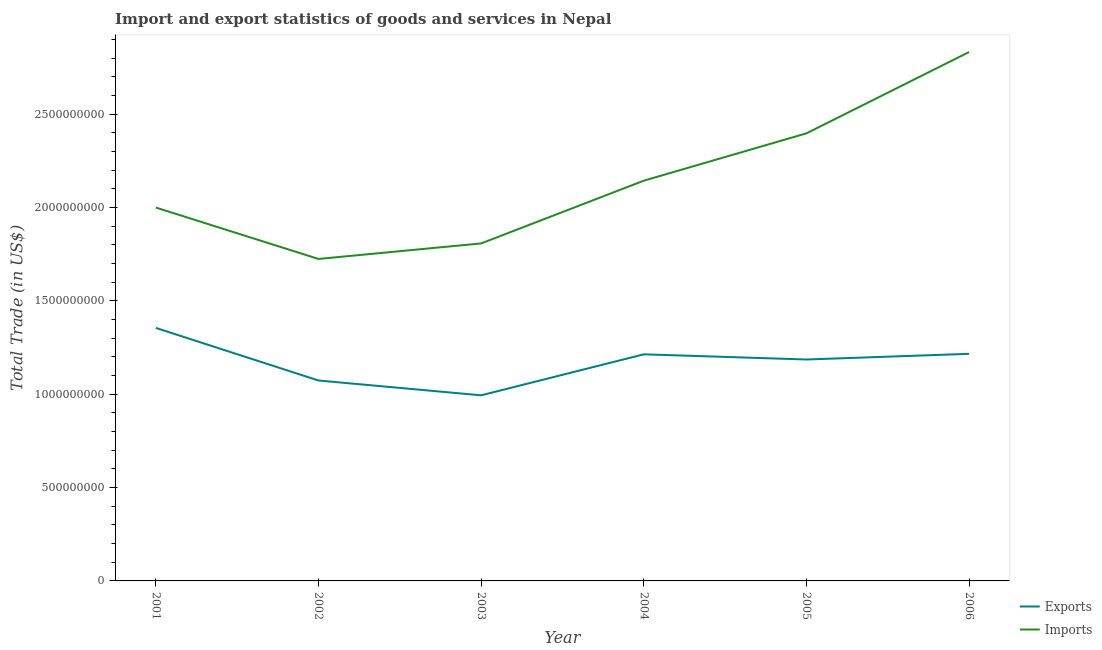How many different coloured lines are there?
Your answer should be compact. 2. Does the line corresponding to export of goods and services intersect with the line corresponding to imports of goods and services?
Your answer should be compact. No. What is the imports of goods and services in 2001?
Give a very brief answer. 2.00e+09. Across all years, what is the maximum imports of goods and services?
Ensure brevity in your answer.  2.83e+09. Across all years, what is the minimum imports of goods and services?
Your response must be concise. 1.72e+09. In which year was the imports of goods and services maximum?
Ensure brevity in your answer.  2006. In which year was the export of goods and services minimum?
Offer a very short reply. 2003. What is the total imports of goods and services in the graph?
Your answer should be very brief. 1.29e+1. What is the difference between the imports of goods and services in 2001 and that in 2002?
Provide a short and direct response. 2.75e+08. What is the difference between the export of goods and services in 2006 and the imports of goods and services in 2003?
Provide a succinct answer. -5.91e+08. What is the average imports of goods and services per year?
Provide a short and direct response. 2.15e+09. In the year 2005, what is the difference between the imports of goods and services and export of goods and services?
Your answer should be very brief. 1.21e+09. In how many years, is the imports of goods and services greater than 1500000000 US$?
Offer a terse response. 6. What is the ratio of the export of goods and services in 2005 to that in 2006?
Keep it short and to the point. 0.98. What is the difference between the highest and the second highest imports of goods and services?
Your answer should be very brief. 4.35e+08. What is the difference between the highest and the lowest export of goods and services?
Your answer should be compact. 3.61e+08. Is the imports of goods and services strictly greater than the export of goods and services over the years?
Your answer should be compact. Yes. How many years are there in the graph?
Ensure brevity in your answer.  6. Are the values on the major ticks of Y-axis written in scientific E-notation?
Provide a succinct answer. No. Does the graph contain any zero values?
Provide a short and direct response. No. Does the graph contain grids?
Your answer should be very brief. No. How many legend labels are there?
Provide a succinct answer. 2. How are the legend labels stacked?
Keep it short and to the point. Vertical. What is the title of the graph?
Offer a very short reply. Import and export statistics of goods and services in Nepal. What is the label or title of the X-axis?
Offer a terse response. Year. What is the label or title of the Y-axis?
Keep it short and to the point. Total Trade (in US$). What is the Total Trade (in US$) of Exports in 2001?
Provide a short and direct response. 1.35e+09. What is the Total Trade (in US$) in Imports in 2001?
Your answer should be very brief. 2.00e+09. What is the Total Trade (in US$) in Exports in 2002?
Give a very brief answer. 1.07e+09. What is the Total Trade (in US$) of Imports in 2002?
Offer a very short reply. 1.72e+09. What is the Total Trade (in US$) in Exports in 2003?
Keep it short and to the point. 9.94e+08. What is the Total Trade (in US$) of Imports in 2003?
Give a very brief answer. 1.81e+09. What is the Total Trade (in US$) of Exports in 2004?
Your answer should be very brief. 1.21e+09. What is the Total Trade (in US$) of Imports in 2004?
Your response must be concise. 2.14e+09. What is the Total Trade (in US$) of Exports in 2005?
Your response must be concise. 1.19e+09. What is the Total Trade (in US$) in Imports in 2005?
Your answer should be compact. 2.40e+09. What is the Total Trade (in US$) in Exports in 2006?
Provide a succinct answer. 1.22e+09. What is the Total Trade (in US$) of Imports in 2006?
Provide a short and direct response. 2.83e+09. Across all years, what is the maximum Total Trade (in US$) in Exports?
Ensure brevity in your answer.  1.35e+09. Across all years, what is the maximum Total Trade (in US$) in Imports?
Keep it short and to the point. 2.83e+09. Across all years, what is the minimum Total Trade (in US$) of Exports?
Offer a very short reply. 9.94e+08. Across all years, what is the minimum Total Trade (in US$) of Imports?
Keep it short and to the point. 1.72e+09. What is the total Total Trade (in US$) in Exports in the graph?
Your answer should be compact. 7.04e+09. What is the total Total Trade (in US$) in Imports in the graph?
Your response must be concise. 1.29e+1. What is the difference between the Total Trade (in US$) in Exports in 2001 and that in 2002?
Provide a succinct answer. 2.82e+08. What is the difference between the Total Trade (in US$) in Imports in 2001 and that in 2002?
Keep it short and to the point. 2.75e+08. What is the difference between the Total Trade (in US$) of Exports in 2001 and that in 2003?
Your response must be concise. 3.61e+08. What is the difference between the Total Trade (in US$) in Imports in 2001 and that in 2003?
Offer a terse response. 1.92e+08. What is the difference between the Total Trade (in US$) in Exports in 2001 and that in 2004?
Your response must be concise. 1.41e+08. What is the difference between the Total Trade (in US$) in Imports in 2001 and that in 2004?
Provide a succinct answer. -1.44e+08. What is the difference between the Total Trade (in US$) in Exports in 2001 and that in 2005?
Give a very brief answer. 1.69e+08. What is the difference between the Total Trade (in US$) of Imports in 2001 and that in 2005?
Your response must be concise. -3.97e+08. What is the difference between the Total Trade (in US$) in Exports in 2001 and that in 2006?
Your answer should be very brief. 1.39e+08. What is the difference between the Total Trade (in US$) of Imports in 2001 and that in 2006?
Your answer should be compact. -8.33e+08. What is the difference between the Total Trade (in US$) of Exports in 2002 and that in 2003?
Provide a short and direct response. 7.94e+07. What is the difference between the Total Trade (in US$) in Imports in 2002 and that in 2003?
Your response must be concise. -8.31e+07. What is the difference between the Total Trade (in US$) of Exports in 2002 and that in 2004?
Provide a succinct answer. -1.40e+08. What is the difference between the Total Trade (in US$) of Imports in 2002 and that in 2004?
Your answer should be very brief. -4.19e+08. What is the difference between the Total Trade (in US$) of Exports in 2002 and that in 2005?
Offer a very short reply. -1.12e+08. What is the difference between the Total Trade (in US$) of Imports in 2002 and that in 2005?
Provide a succinct answer. -6.73e+08. What is the difference between the Total Trade (in US$) in Exports in 2002 and that in 2006?
Ensure brevity in your answer.  -1.43e+08. What is the difference between the Total Trade (in US$) in Imports in 2002 and that in 2006?
Make the answer very short. -1.11e+09. What is the difference between the Total Trade (in US$) of Exports in 2003 and that in 2004?
Provide a succinct answer. -2.20e+08. What is the difference between the Total Trade (in US$) of Imports in 2003 and that in 2004?
Your answer should be very brief. -3.36e+08. What is the difference between the Total Trade (in US$) in Exports in 2003 and that in 2005?
Your answer should be very brief. -1.92e+08. What is the difference between the Total Trade (in US$) in Imports in 2003 and that in 2005?
Your answer should be very brief. -5.90e+08. What is the difference between the Total Trade (in US$) in Exports in 2003 and that in 2006?
Provide a short and direct response. -2.22e+08. What is the difference between the Total Trade (in US$) in Imports in 2003 and that in 2006?
Give a very brief answer. -1.02e+09. What is the difference between the Total Trade (in US$) in Exports in 2004 and that in 2005?
Offer a terse response. 2.78e+07. What is the difference between the Total Trade (in US$) of Imports in 2004 and that in 2005?
Keep it short and to the point. -2.54e+08. What is the difference between the Total Trade (in US$) in Exports in 2004 and that in 2006?
Your response must be concise. -2.58e+06. What is the difference between the Total Trade (in US$) of Imports in 2004 and that in 2006?
Your response must be concise. -6.89e+08. What is the difference between the Total Trade (in US$) in Exports in 2005 and that in 2006?
Provide a short and direct response. -3.04e+07. What is the difference between the Total Trade (in US$) of Imports in 2005 and that in 2006?
Provide a succinct answer. -4.35e+08. What is the difference between the Total Trade (in US$) of Exports in 2001 and the Total Trade (in US$) of Imports in 2002?
Offer a terse response. -3.69e+08. What is the difference between the Total Trade (in US$) of Exports in 2001 and the Total Trade (in US$) of Imports in 2003?
Your answer should be compact. -4.52e+08. What is the difference between the Total Trade (in US$) in Exports in 2001 and the Total Trade (in US$) in Imports in 2004?
Your response must be concise. -7.88e+08. What is the difference between the Total Trade (in US$) in Exports in 2001 and the Total Trade (in US$) in Imports in 2005?
Your response must be concise. -1.04e+09. What is the difference between the Total Trade (in US$) in Exports in 2001 and the Total Trade (in US$) in Imports in 2006?
Provide a short and direct response. -1.48e+09. What is the difference between the Total Trade (in US$) in Exports in 2002 and the Total Trade (in US$) in Imports in 2003?
Your response must be concise. -7.34e+08. What is the difference between the Total Trade (in US$) of Exports in 2002 and the Total Trade (in US$) of Imports in 2004?
Keep it short and to the point. -1.07e+09. What is the difference between the Total Trade (in US$) in Exports in 2002 and the Total Trade (in US$) in Imports in 2005?
Keep it short and to the point. -1.32e+09. What is the difference between the Total Trade (in US$) in Exports in 2002 and the Total Trade (in US$) in Imports in 2006?
Keep it short and to the point. -1.76e+09. What is the difference between the Total Trade (in US$) in Exports in 2003 and the Total Trade (in US$) in Imports in 2004?
Your answer should be compact. -1.15e+09. What is the difference between the Total Trade (in US$) of Exports in 2003 and the Total Trade (in US$) of Imports in 2005?
Your answer should be very brief. -1.40e+09. What is the difference between the Total Trade (in US$) in Exports in 2003 and the Total Trade (in US$) in Imports in 2006?
Keep it short and to the point. -1.84e+09. What is the difference between the Total Trade (in US$) in Exports in 2004 and the Total Trade (in US$) in Imports in 2005?
Offer a terse response. -1.18e+09. What is the difference between the Total Trade (in US$) in Exports in 2004 and the Total Trade (in US$) in Imports in 2006?
Provide a succinct answer. -1.62e+09. What is the difference between the Total Trade (in US$) of Exports in 2005 and the Total Trade (in US$) of Imports in 2006?
Provide a short and direct response. -1.65e+09. What is the average Total Trade (in US$) of Exports per year?
Offer a very short reply. 1.17e+09. What is the average Total Trade (in US$) of Imports per year?
Ensure brevity in your answer.  2.15e+09. In the year 2001, what is the difference between the Total Trade (in US$) of Exports and Total Trade (in US$) of Imports?
Provide a short and direct response. -6.45e+08. In the year 2002, what is the difference between the Total Trade (in US$) of Exports and Total Trade (in US$) of Imports?
Keep it short and to the point. -6.51e+08. In the year 2003, what is the difference between the Total Trade (in US$) of Exports and Total Trade (in US$) of Imports?
Keep it short and to the point. -8.13e+08. In the year 2004, what is the difference between the Total Trade (in US$) of Exports and Total Trade (in US$) of Imports?
Keep it short and to the point. -9.30e+08. In the year 2005, what is the difference between the Total Trade (in US$) of Exports and Total Trade (in US$) of Imports?
Keep it short and to the point. -1.21e+09. In the year 2006, what is the difference between the Total Trade (in US$) of Exports and Total Trade (in US$) of Imports?
Your response must be concise. -1.62e+09. What is the ratio of the Total Trade (in US$) of Exports in 2001 to that in 2002?
Offer a very short reply. 1.26. What is the ratio of the Total Trade (in US$) in Imports in 2001 to that in 2002?
Ensure brevity in your answer.  1.16. What is the ratio of the Total Trade (in US$) in Exports in 2001 to that in 2003?
Give a very brief answer. 1.36. What is the ratio of the Total Trade (in US$) of Imports in 2001 to that in 2003?
Offer a terse response. 1.11. What is the ratio of the Total Trade (in US$) of Exports in 2001 to that in 2004?
Your answer should be compact. 1.12. What is the ratio of the Total Trade (in US$) in Imports in 2001 to that in 2004?
Your answer should be compact. 0.93. What is the ratio of the Total Trade (in US$) of Exports in 2001 to that in 2005?
Offer a terse response. 1.14. What is the ratio of the Total Trade (in US$) of Imports in 2001 to that in 2005?
Make the answer very short. 0.83. What is the ratio of the Total Trade (in US$) of Exports in 2001 to that in 2006?
Your answer should be very brief. 1.11. What is the ratio of the Total Trade (in US$) in Imports in 2001 to that in 2006?
Your response must be concise. 0.71. What is the ratio of the Total Trade (in US$) of Exports in 2002 to that in 2003?
Ensure brevity in your answer.  1.08. What is the ratio of the Total Trade (in US$) in Imports in 2002 to that in 2003?
Make the answer very short. 0.95. What is the ratio of the Total Trade (in US$) of Exports in 2002 to that in 2004?
Provide a short and direct response. 0.88. What is the ratio of the Total Trade (in US$) in Imports in 2002 to that in 2004?
Your response must be concise. 0.8. What is the ratio of the Total Trade (in US$) in Exports in 2002 to that in 2005?
Give a very brief answer. 0.91. What is the ratio of the Total Trade (in US$) of Imports in 2002 to that in 2005?
Give a very brief answer. 0.72. What is the ratio of the Total Trade (in US$) of Exports in 2002 to that in 2006?
Your response must be concise. 0.88. What is the ratio of the Total Trade (in US$) in Imports in 2002 to that in 2006?
Provide a short and direct response. 0.61. What is the ratio of the Total Trade (in US$) of Exports in 2003 to that in 2004?
Provide a short and direct response. 0.82. What is the ratio of the Total Trade (in US$) in Imports in 2003 to that in 2004?
Keep it short and to the point. 0.84. What is the ratio of the Total Trade (in US$) in Exports in 2003 to that in 2005?
Provide a succinct answer. 0.84. What is the ratio of the Total Trade (in US$) of Imports in 2003 to that in 2005?
Keep it short and to the point. 0.75. What is the ratio of the Total Trade (in US$) of Exports in 2003 to that in 2006?
Offer a terse response. 0.82. What is the ratio of the Total Trade (in US$) in Imports in 2003 to that in 2006?
Your answer should be compact. 0.64. What is the ratio of the Total Trade (in US$) of Exports in 2004 to that in 2005?
Offer a terse response. 1.02. What is the ratio of the Total Trade (in US$) of Imports in 2004 to that in 2005?
Make the answer very short. 0.89. What is the ratio of the Total Trade (in US$) of Imports in 2004 to that in 2006?
Provide a succinct answer. 0.76. What is the ratio of the Total Trade (in US$) in Exports in 2005 to that in 2006?
Keep it short and to the point. 0.97. What is the ratio of the Total Trade (in US$) in Imports in 2005 to that in 2006?
Keep it short and to the point. 0.85. What is the difference between the highest and the second highest Total Trade (in US$) of Exports?
Provide a succinct answer. 1.39e+08. What is the difference between the highest and the second highest Total Trade (in US$) in Imports?
Offer a very short reply. 4.35e+08. What is the difference between the highest and the lowest Total Trade (in US$) of Exports?
Your answer should be very brief. 3.61e+08. What is the difference between the highest and the lowest Total Trade (in US$) of Imports?
Keep it short and to the point. 1.11e+09. 